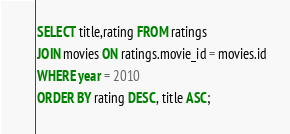<code> <loc_0><loc_0><loc_500><loc_500><_SQL_>SELECT title,rating FROM ratings
JOIN movies ON ratings.movie_id = movies.id
WHERE year = 2010
ORDER BY rating DESC, title ASC;</code> 